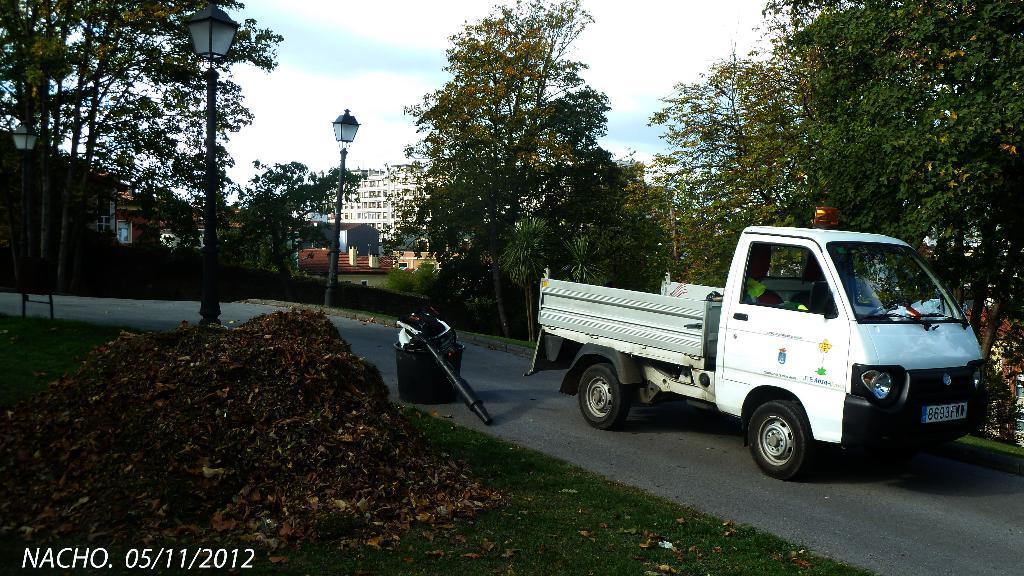Please provide a concise description of this image. In the center of the image there is a road. There is a truck on the road. On the left there are poles. On the right there are trees. In the background there is a building and sky. 